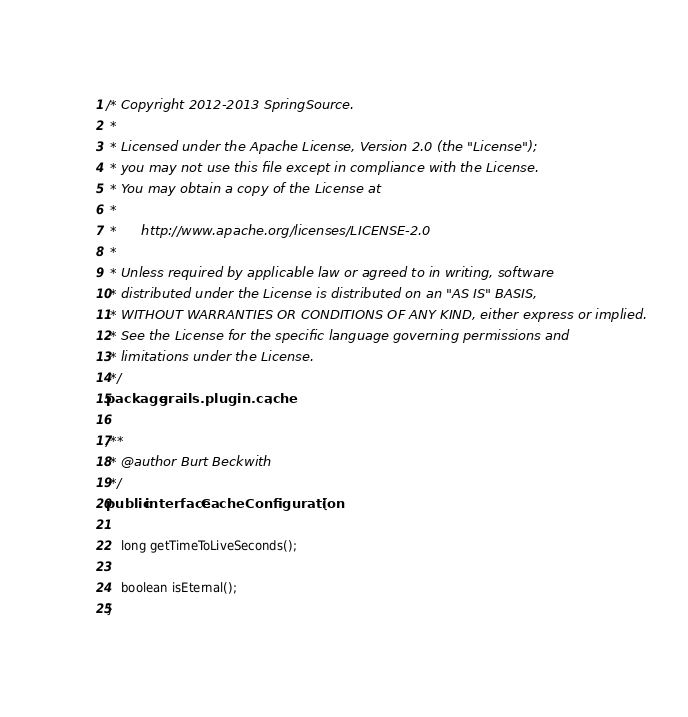<code> <loc_0><loc_0><loc_500><loc_500><_Java_>/* Copyright 2012-2013 SpringSource.
 *
 * Licensed under the Apache License, Version 2.0 (the "License");
 * you may not use this file except in compliance with the License.
 * You may obtain a copy of the License at
 *
 *      http://www.apache.org/licenses/LICENSE-2.0
 *
 * Unless required by applicable law or agreed to in writing, software
 * distributed under the License is distributed on an "AS IS" BASIS,
 * WITHOUT WARRANTIES OR CONDITIONS OF ANY KIND, either express or implied.
 * See the License for the specific language governing permissions and
 * limitations under the License.
 */
package grails.plugin.cache;

/**
 * @author Burt Beckwith
 */
public interface CacheConfiguration {

	long getTimeToLiveSeconds();

	boolean isEternal();
}
</code> 